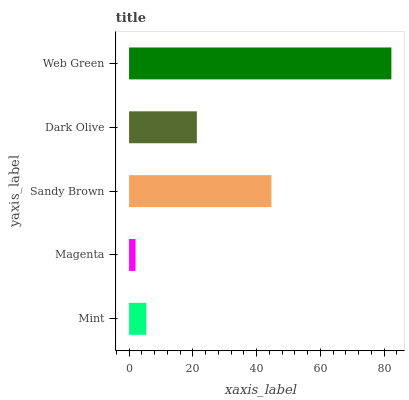Is Magenta the minimum?
Answer yes or no. Yes. Is Web Green the maximum?
Answer yes or no. Yes. Is Sandy Brown the minimum?
Answer yes or no. No. Is Sandy Brown the maximum?
Answer yes or no. No. Is Sandy Brown greater than Magenta?
Answer yes or no. Yes. Is Magenta less than Sandy Brown?
Answer yes or no. Yes. Is Magenta greater than Sandy Brown?
Answer yes or no. No. Is Sandy Brown less than Magenta?
Answer yes or no. No. Is Dark Olive the high median?
Answer yes or no. Yes. Is Dark Olive the low median?
Answer yes or no. Yes. Is Web Green the high median?
Answer yes or no. No. Is Mint the low median?
Answer yes or no. No. 